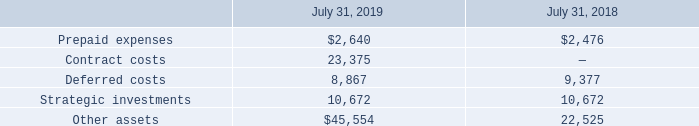Other Assets
Other assets consist of the following (in thousands):
The Company’s other assets includes a strategic equity investment in a privately-held company. The strategic investment is a non-marketable equity security, in which the Company does not have a controlling interest or the ability to exert significant influence. This investment does not have a readily determinable market value. The Company records this strategic investment at cost less impairment and adjusts cost for subsequent observable price changes. During the years ended July 31, 2019 and 2018, there were no changes in the investment’s carrying value of $10.7 million.
What does the company's other assets include? A strategic equity investment in a privately-held company. What was the investment's carrying value in 2019? $10.7 million. What was the Prepaid expenses in 2019 and 2018 respectively?
Answer scale should be: thousand. $2,640, $2,476. What was the average Contract costs for 2018 and 2019?
Answer scale should be: thousand. (23,375 + 0) / 2
Answer: 11687.5. What was the change in the Deferred costs from 2018 to 2019?
Answer scale should be: thousand. 8,867 - 9,377
Answer: -510. In which year was Other assets less than 30,000 thousands? Locate and analyze other assets in row 6
answer: 2018. 